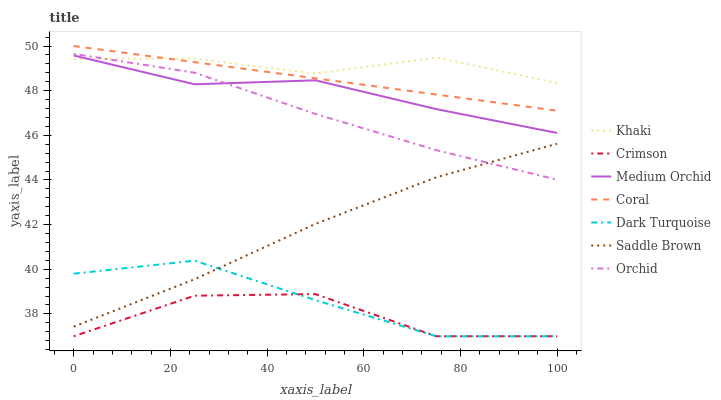Does Crimson have the minimum area under the curve?
Answer yes or no. Yes. Does Khaki have the maximum area under the curve?
Answer yes or no. Yes. Does Dark Turquoise have the minimum area under the curve?
Answer yes or no. No. Does Dark Turquoise have the maximum area under the curve?
Answer yes or no. No. Is Coral the smoothest?
Answer yes or no. Yes. Is Crimson the roughest?
Answer yes or no. Yes. Is Dark Turquoise the smoothest?
Answer yes or no. No. Is Dark Turquoise the roughest?
Answer yes or no. No. Does Dark Turquoise have the lowest value?
Answer yes or no. Yes. Does Coral have the lowest value?
Answer yes or no. No. Does Coral have the highest value?
Answer yes or no. Yes. Does Dark Turquoise have the highest value?
Answer yes or no. No. Is Saddle Brown less than Khaki?
Answer yes or no. Yes. Is Khaki greater than Saddle Brown?
Answer yes or no. Yes. Does Dark Turquoise intersect Crimson?
Answer yes or no. Yes. Is Dark Turquoise less than Crimson?
Answer yes or no. No. Is Dark Turquoise greater than Crimson?
Answer yes or no. No. Does Saddle Brown intersect Khaki?
Answer yes or no. No. 